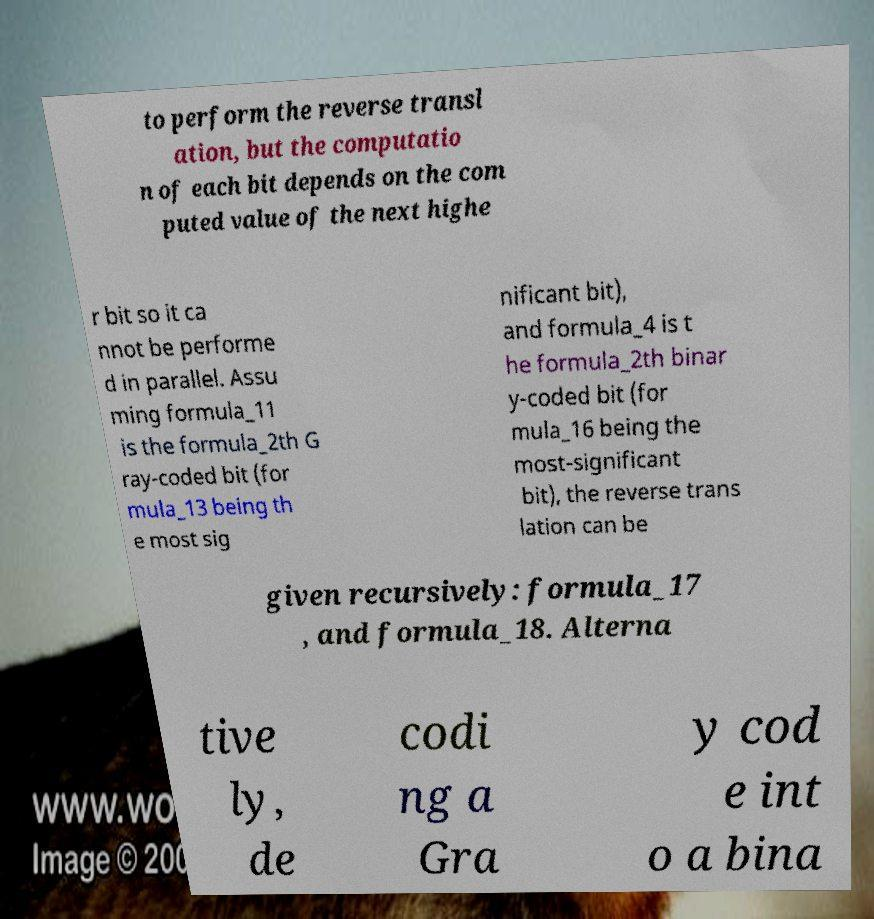Please identify and transcribe the text found in this image. to perform the reverse transl ation, but the computatio n of each bit depends on the com puted value of the next highe r bit so it ca nnot be performe d in parallel. Assu ming formula_11 is the formula_2th G ray-coded bit (for mula_13 being th e most sig nificant bit), and formula_4 is t he formula_2th binar y-coded bit (for mula_16 being the most-significant bit), the reverse trans lation can be given recursively: formula_17 , and formula_18. Alterna tive ly, de codi ng a Gra y cod e int o a bina 